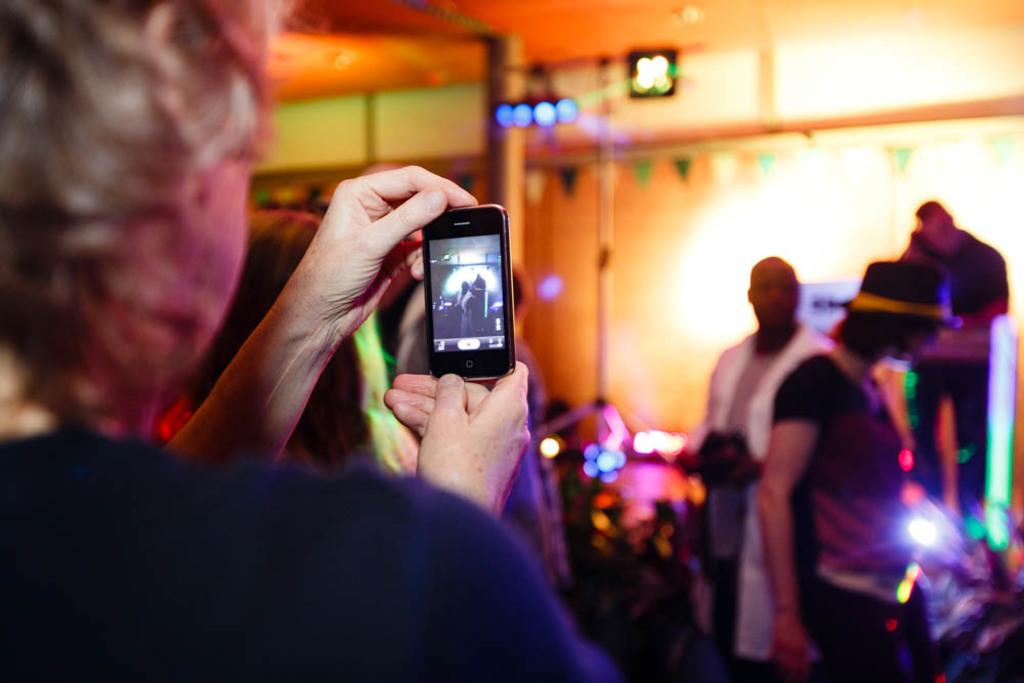What can be seen in the image that provides illumination? There are lights in the image. What else is visible in the image besides the lights? There are people standing in the image. Can you describe the actions of one of the individuals in the image? One woman is holding a mobile in her hand and is recording with her mobile. What type of show is the woman recording with her mobile in the image? There is no indication in the image that the woman is recording a show or any specific event. 